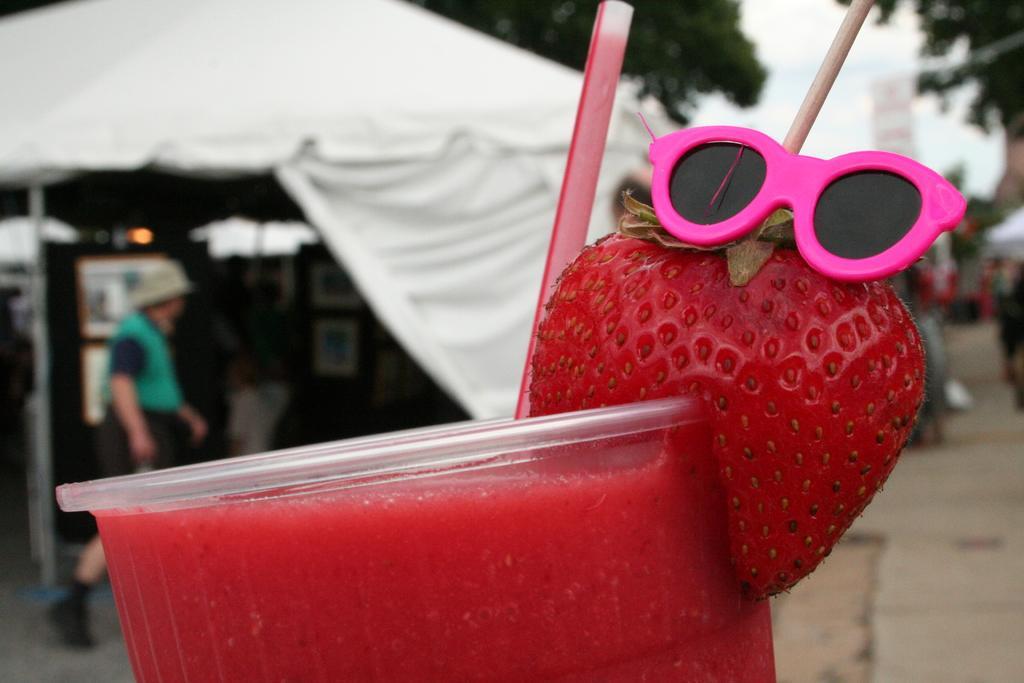Please provide a concise description of this image. In this image, we can see a glass with some objects. We can see the ground. In the background, we can see a person and a white colored tent. There are a few trees. We can see the sky. 